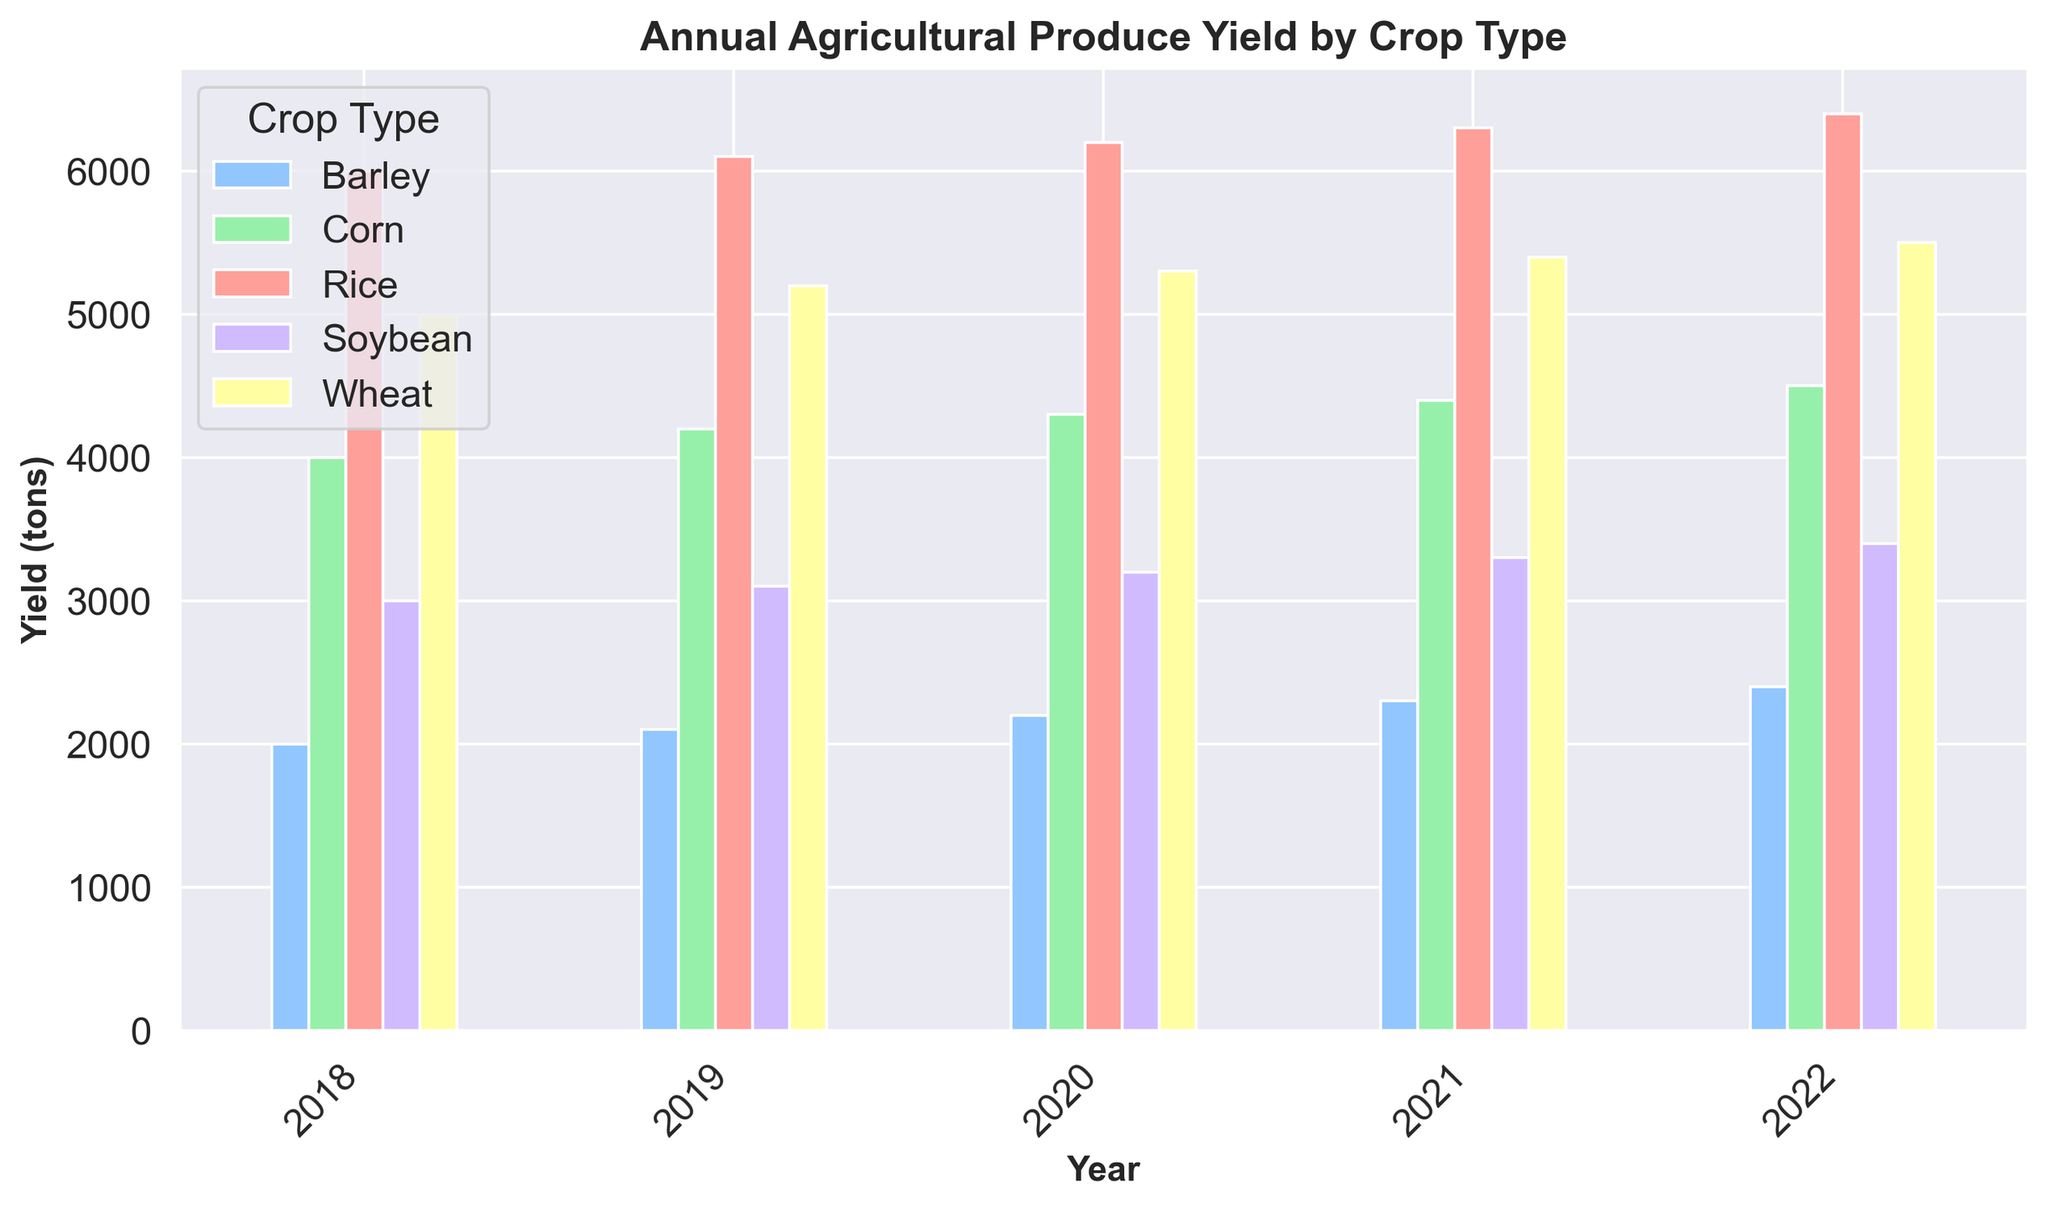What is the total yield of Corn over the 5 years shown? Sum the yields of Corn for the years 2018, 2019, 2020, 2021, and 2022. The yields are 4000, 4200, 4300, 4400, and 4500 respectively. So, 4000 + 4200 + 4300 + 4400 + 4500 = 21400 tons.
Answer: 21400 tons Which crop had the highest yield in 2021? Compare the yields of different crops in 2021. The yields are Wheat (5400), Rice (6300), Corn (4400), Barley (2300), and Soybean (3300). Rice has the highest yield of 6300 tons.
Answer: Rice How does the yield of Barley in 2019 compare to its yield in 2020? Check the yields of Barley in 2019 (2100 tons) and 2020 (2200 tons). The yield increased by 100 tons from 2019 to 2020.
Answer: It increased by 100 tons What is the average annual yield of Rice over the five-year period? Sum the yields of Rice for the years 2018, 2019, 2020, 2021, and 2022, then divide by 5. The yields are 6000, 6100, 6200, 6300, and 6400 respectively. So, (6000 + 6100 + 6200 + 6300 + 6400) / 5 = 6200 tons.
Answer: 6200 tons Which year recorded the lowest yield for Soybean? Compare the yields of Soybean across all years. The yields are 3000 (2018), 3100 (2019), 3200 (2020), 3300 (2021), and 3400 (2022). The lowest yield is 3000 tons in 2018.
Answer: 2018 In which year did Wheat yield surpass 5000 tons for the first time? Check the yields of Wheat year by year. In 2018, it was 5000 tons; in 2019, it was 5200 tons. The first year it surpassed 5000 tons was 2019.
Answer: 2019 What is the total yield of all crops in 2022? Sum the yields of all crops in 2022. The yields are Wheat (5500), Rice (6400), Corn (4500), Barley (2400), and Soybean (3400). So, 5500 + 6400 + 4500 + 2400 + 3400 = 22200 tons.
Answer: 22200 tons Which crop shows the most consistent increase in yield across the years? Examine the yield trend for each crop. Wheat increases consistently from 5000 to 5500, Rice from 6000 to 6400, Corn from 4000 to 4500, Barley from 2000 to 2400, and Soybean from 3000 to 3400. Rice shows the most consistent increase.
Answer: Rice How much greater was the yield of Rice compared to Corn in 2020? Compare the yields of Rice and Corn in 2020. Rice yield is 6200 tons and Corn yield is 4300 tons. The difference is 6200 - 4300 = 1900 tons.
Answer: 1900 tons What is the difference in yield between the highest and lowest yielding crops in 2019? Identify the highest and lowest yields in 2019. Rice has the highest yield at 6100 tons, and Barley has the lowest yield at 2100 tons. The difference is 6100 - 2100 = 4000 tons.
Answer: 4000 tons 